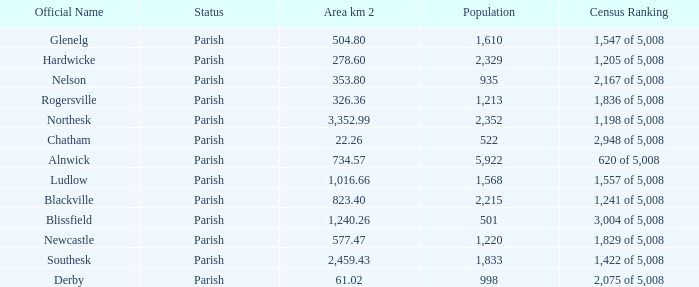Can you tell me the sum of Area km 2 that has the Official Name of glenelg? 504.8. 